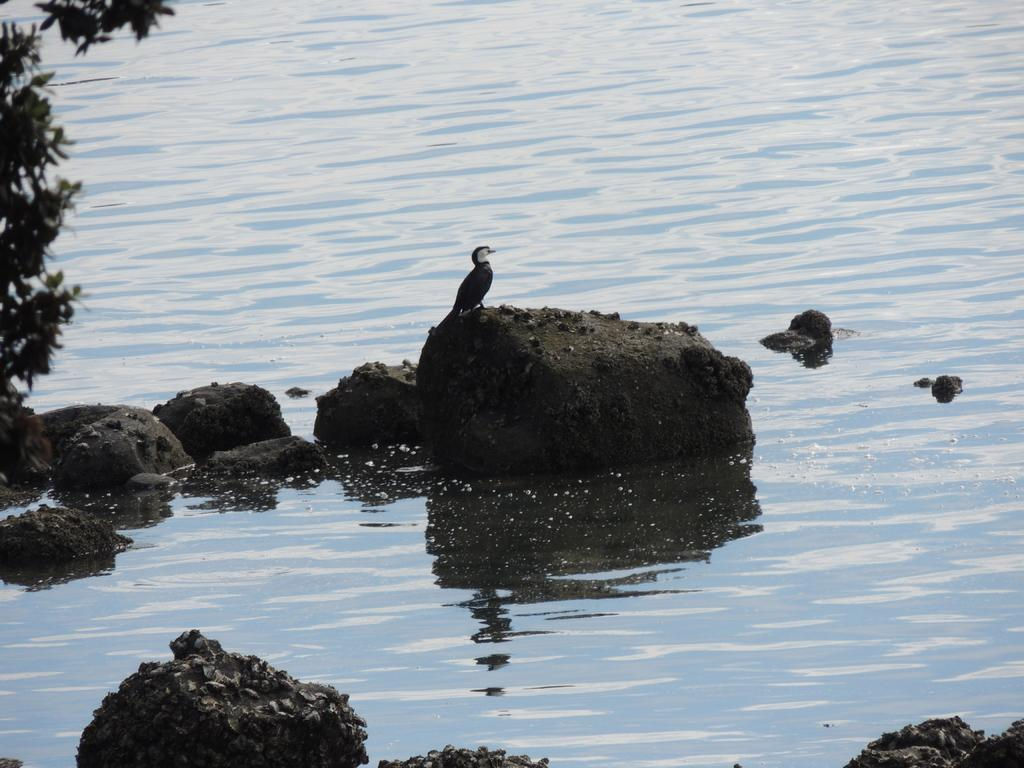What is the main subject of the image? There is a bird standing on a rock in the image. Where is the rock located? The rock is on water. What type of vegetation can be seen in the image? There are leaves on branches on the left side of the image. What else can be seen at the bottom of the image? There are rocks visible at the bottom of the image. What songs is the bird singing in the image? The image does not provide any information about the bird singing songs. 